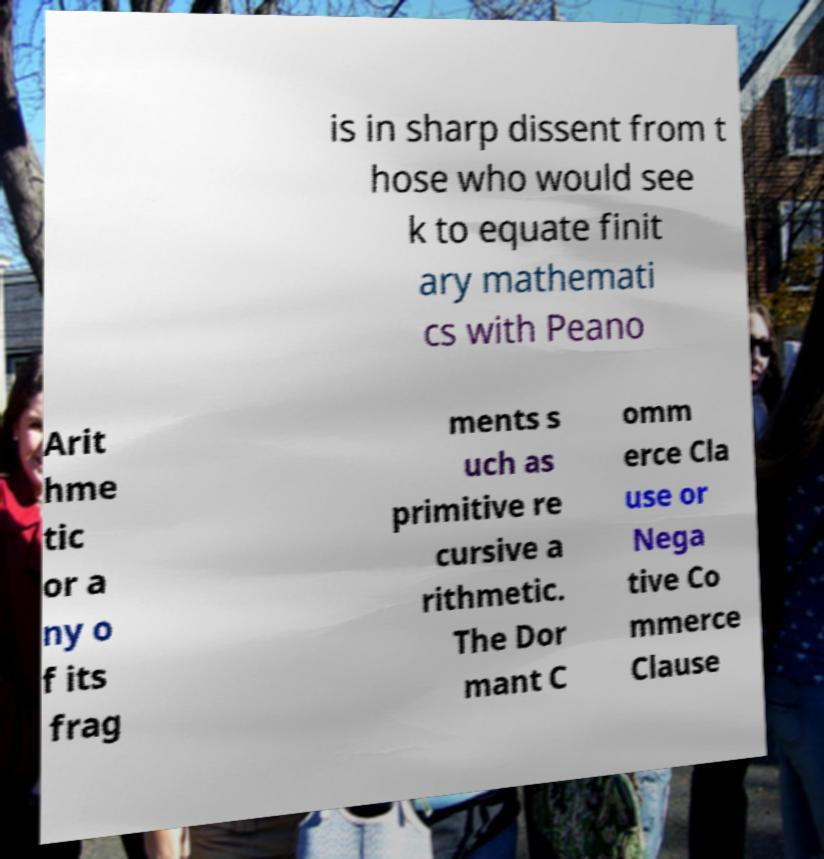I need the written content from this picture converted into text. Can you do that? is in sharp dissent from t hose who would see k to equate finit ary mathemati cs with Peano Arit hme tic or a ny o f its frag ments s uch as primitive re cursive a rithmetic. The Dor mant C omm erce Cla use or Nega tive Co mmerce Clause 